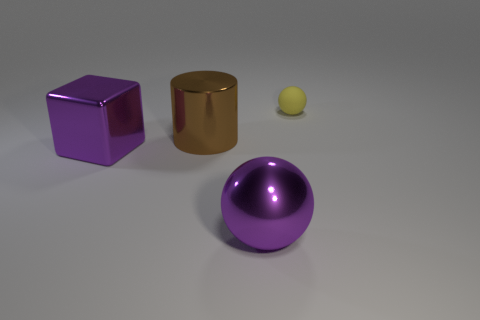There is a large metallic thing that is the same color as the large block; what is its shape?
Ensure brevity in your answer.  Sphere. What number of cylinders are brown shiny things or tiny green metallic objects?
Offer a terse response. 1. There is a brown metal cylinder; is its size the same as the sphere that is to the left of the tiny yellow thing?
Offer a very short reply. Yes. Is the number of large purple metallic blocks that are on the right side of the purple cube greater than the number of cylinders?
Ensure brevity in your answer.  No. There is a purple object that is the same material as the big purple sphere; what size is it?
Offer a terse response. Large. Is there a cube of the same color as the metallic sphere?
Your answer should be compact. Yes. What number of things are either purple metal balls or objects left of the big brown cylinder?
Make the answer very short. 2. Are there more yellow objects than cyan metal cylinders?
Your answer should be compact. Yes. What size is the cube that is the same color as the metal sphere?
Your answer should be very brief. Large. Are there any other small balls made of the same material as the tiny yellow sphere?
Provide a short and direct response. No. 